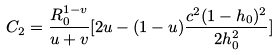<formula> <loc_0><loc_0><loc_500><loc_500>C _ { 2 } = \frac { R _ { 0 } ^ { 1 - v } } { u + v } [ 2 u - ( 1 - u ) \frac { c ^ { 2 } ( 1 - h _ { 0 } ) ^ { 2 } } { 2 h _ { 0 } ^ { 2 } } ]</formula> 